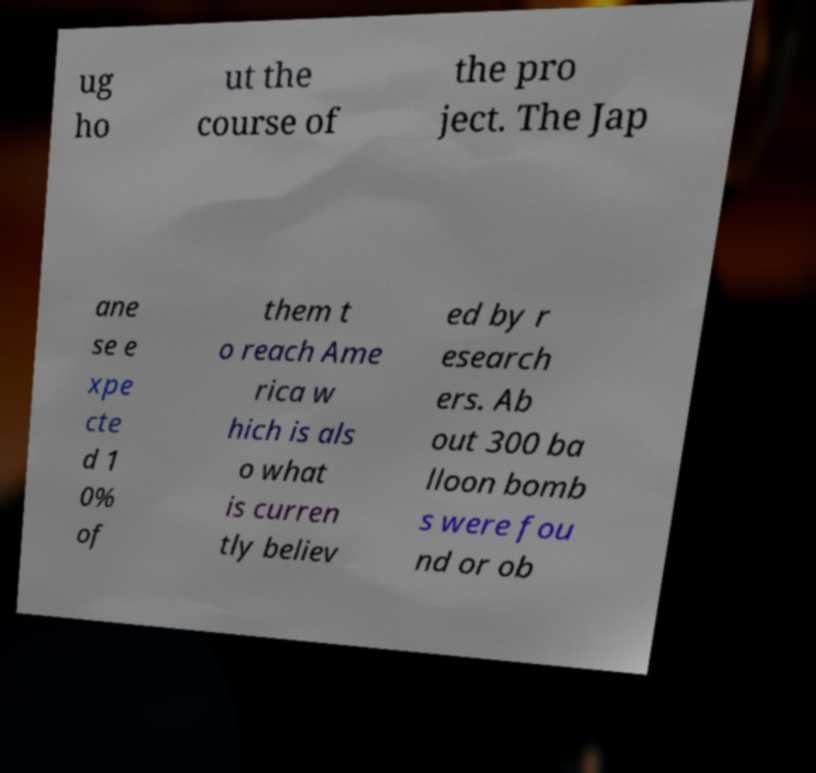Please identify and transcribe the text found in this image. ug ho ut the course of the pro ject. The Jap ane se e xpe cte d 1 0% of them t o reach Ame rica w hich is als o what is curren tly believ ed by r esearch ers. Ab out 300 ba lloon bomb s were fou nd or ob 